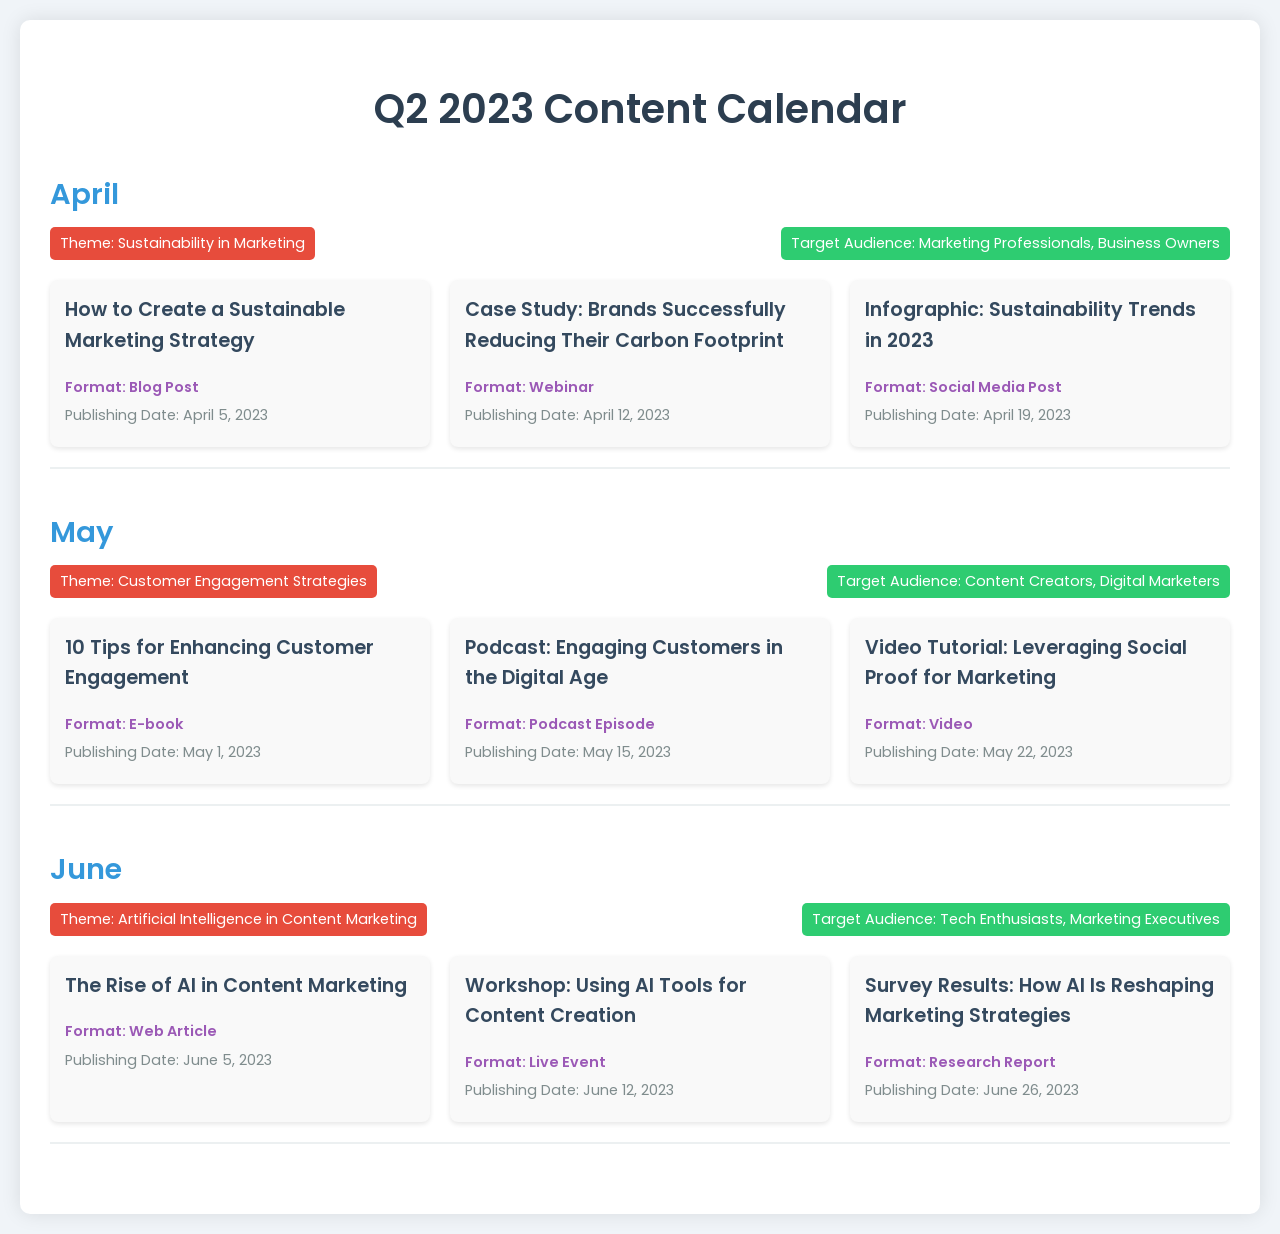What is the theme for April? The theme for April is stated in the document, specifically in the section titled “Month” for April.
Answer: Sustainability in Marketing What date is the post about sustainability strategies published? The publishing date of the blog post regarding sustainable marketing strategy is noted under April.
Answer: April 5, 2023 Which format is used for the Customer Engagement E-book? The format for the content item titled "10 Tips for Enhancing Customer Engagement" is specified in the May section.
Answer: E-book Who is the target audience for the June content? The target audience for June is provided in the month-specific section under "Target Audience."
Answer: Tech Enthusiasts, Marketing Executives How many pieces of content are published in May? The total number of content items listed under May can be counted from the document.
Answer: 3 What is the title of the webinar scheduled for April? The title of the case study mentioned in the April section can be found under the content items.
Answer: Case Study: Brands Successfully Reducing Their Carbon Footprint Which month has the theme related to Artificial Intelligence? The theme related to Artificial Intelligence is specified in the June section of the document.
Answer: June What type of content is scheduled for June 12, 2023? The specific type of content scheduled for June 12 is mentioned in the content items list under June.
Answer: Live Event What are the content types used in April? The various content types listed in April can be found detailed in the content types section.
Answer: Blog Post, Webinar, Social Media Post 